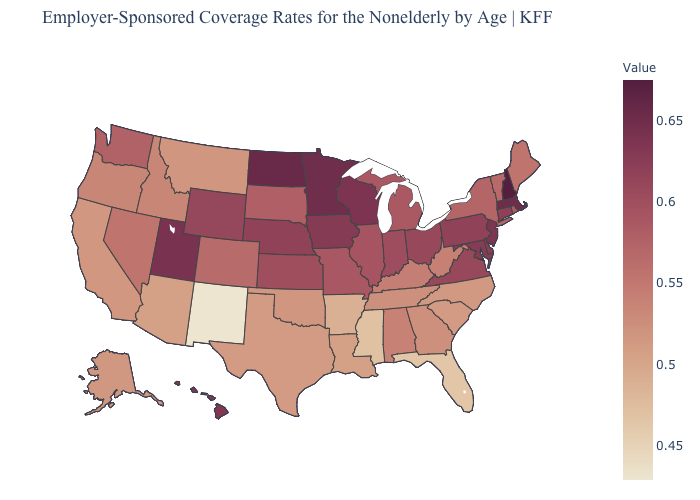Does Utah have the highest value in the West?
Keep it brief. Yes. Which states have the lowest value in the USA?
Be succinct. New Mexico. Among the states that border Illinois , does Indiana have the highest value?
Concise answer only. No. Which states have the lowest value in the USA?
Answer briefly. New Mexico. Which states have the lowest value in the South?
Keep it brief. Florida. Among the states that border Arizona , which have the highest value?
Short answer required. Utah. Does Florida have the lowest value in the South?
Keep it brief. Yes. Among the states that border Iowa , which have the lowest value?
Write a very short answer. South Dakota. Does the map have missing data?
Write a very short answer. No. Which states hav the highest value in the South?
Write a very short answer. Maryland. 